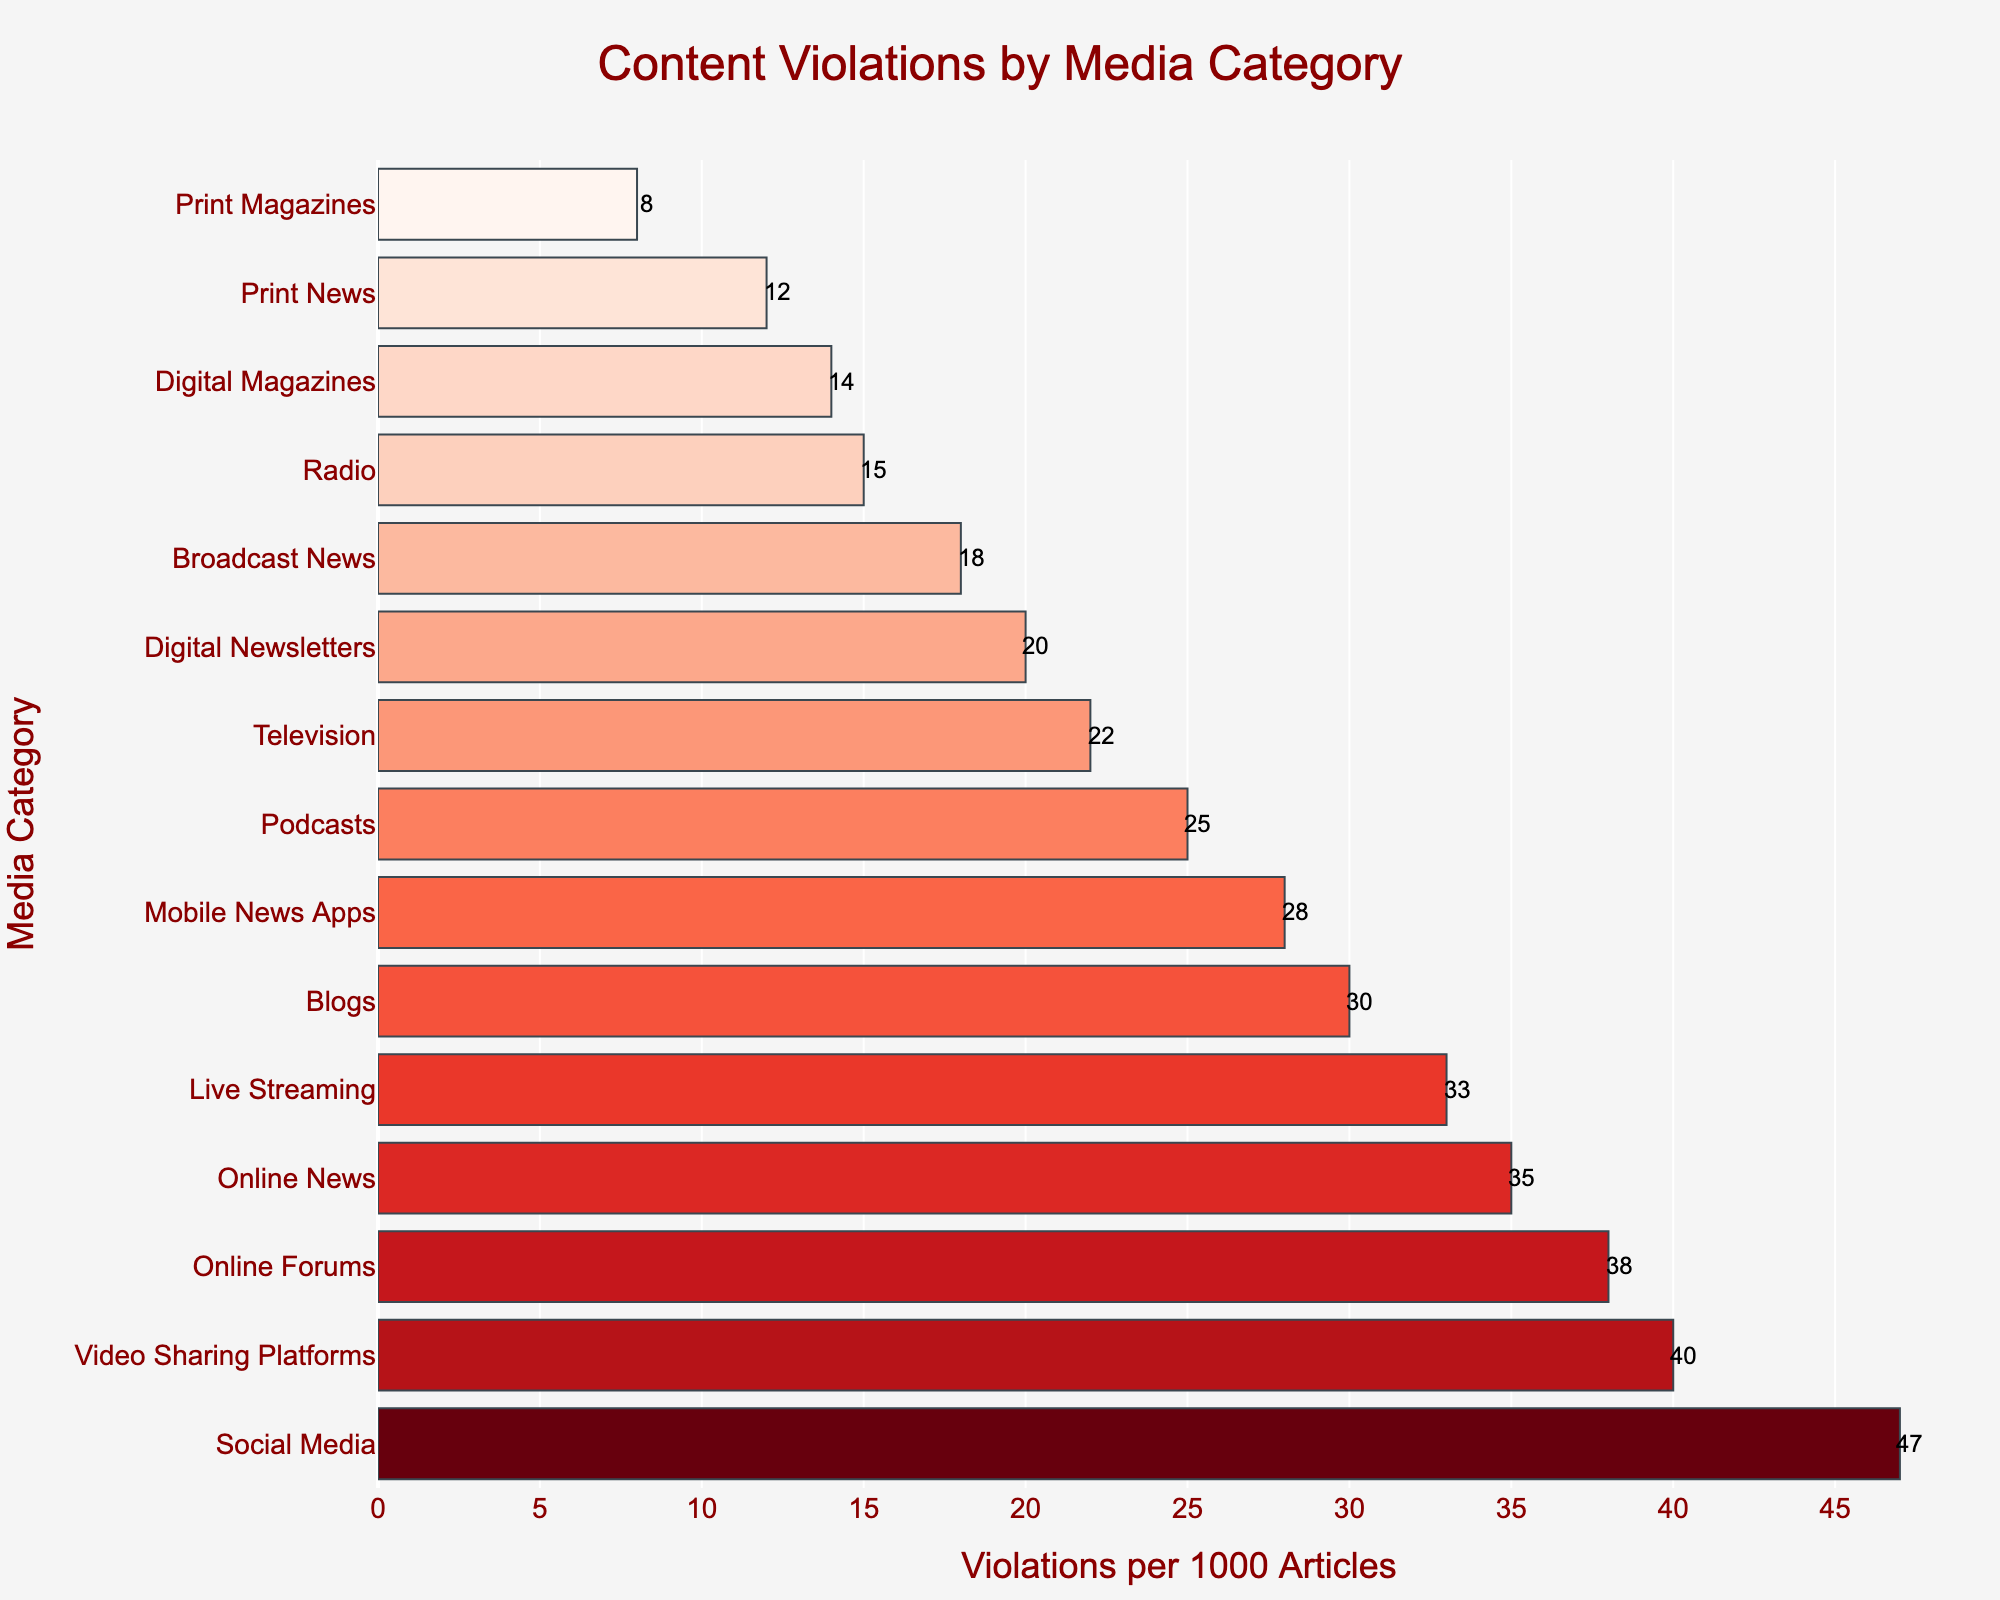Which media category has the highest number of content violations per 1000 articles? Look at the bar with the highest length. The highest length corresponds to the category 'Social Media' with 47 violations.
Answer: Social Media What is the difference in content violations per 1000 articles between Print News and Online News? Identify the values for Print News (12) and Online News (35) and subtract the former from the latter: 35 - 12 = 23.
Answer: 23 Which media category has a lower number of content violations per 1000 articles: Television or Video Sharing Platforms? Compare the values of content violations for Television (22) and Video Sharing Platforms (40). Television has fewer content violations.
Answer: Television What is the average number of content violations per 1000 articles for the categories Radio, Podcasts, and Mobile News Apps? Find the violations for Radio (15), Podcasts (25), and Mobile News Apps (28), then compute the average: (15 + 25 + 28) / 3 = 22.67.
Answer: 22.67 How many more violations per 1000 articles does Live Streaming have compared to Digital Magazines? Identify and subtract the values for Digital Magazines (14) from Live Streaming (33): 33 - 14 = 19.
Answer: 19 Identify the median value of content violations per 1000 articles across all media categories. First, sort the values in ascending order: 8, 12, 14, 15, 18, 20, 22, 25, 28, 30, 33, 35, 38, 40, 47. The middle value (8th) in this sorted list is 22.
Answer: 22 Which category has the shortest bar, representing the lowest content violations per 1000 articles? Look for the shortest bar on the chart, which corresponds to Print Magazines with 8 violations.
Answer: Print Magazines How do the content violations for Blogs compare to those for Digital Newsletters? Compare the violations for Blogs (30) and Digital Newsletters (20). Blogs have more violations.
Answer: Blogs Calculate the combined number of content violations per 1000 articles for Broadcast News, Online Forums, and Digital Newsletters. Sum the violations for Broadcast News (18), Online Forums (38), and Digital Newsletters (20): 18 + 38 + 20 = 76.
Answer: 76 What is the visual difference between the bars representing Podcasts and Live Streaming? Look at the bars. The Podcast bar (25 violations) is shorter and visually lighter in color than the Live Streaming bar (33 violations) which is longer and darker.
Answer: Live Streaming bar is longer and darker 